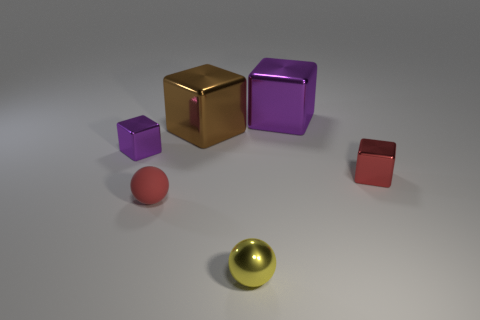Subtract all purple blocks. How many were subtracted if there are1purple blocks left? 1 Subtract 0 yellow cubes. How many objects are left? 6 Subtract all spheres. How many objects are left? 4 Subtract all yellow cubes. Subtract all cyan spheres. How many cubes are left? 4 Subtract all blue cylinders. How many cyan blocks are left? 0 Subtract all big purple objects. Subtract all large brown cubes. How many objects are left? 4 Add 4 small purple objects. How many small purple objects are left? 5 Add 2 yellow cubes. How many yellow cubes exist? 2 Add 2 rubber spheres. How many objects exist? 8 Subtract all brown blocks. How many blocks are left? 3 